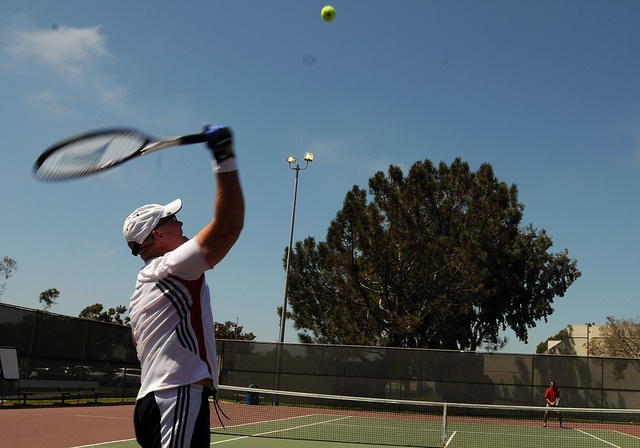Describe the objects in this image and their specific colors. I can see people in gray, black, lightgray, and darkgray tones, tennis racket in gray, darkgray, and black tones, bench in black, darkgreen, and gray tones, car in gray and black tones, and people in gray, black, and maroon tones in this image. 